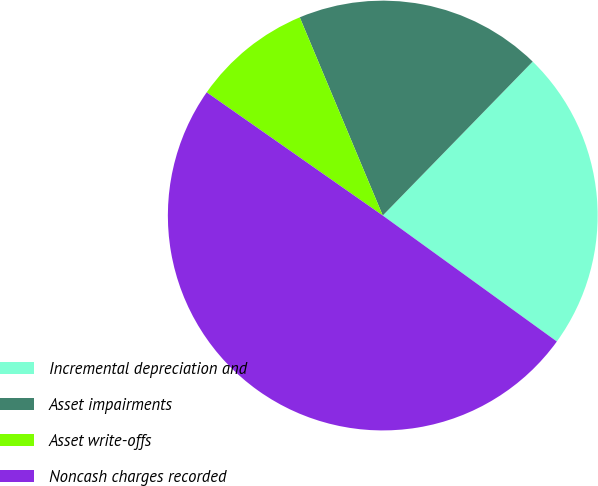Convert chart. <chart><loc_0><loc_0><loc_500><loc_500><pie_chart><fcel>Incremental depreciation and<fcel>Asset impairments<fcel>Asset write-offs<fcel>Noncash charges recorded<nl><fcel>22.68%<fcel>18.6%<fcel>8.97%<fcel>49.75%<nl></chart> 